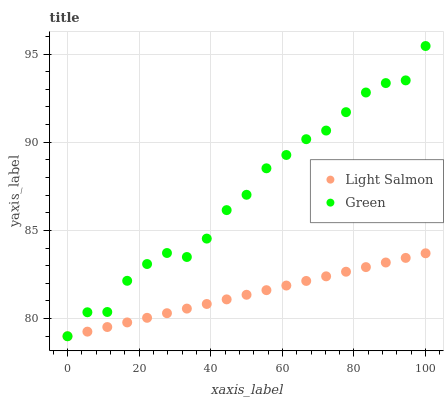Does Light Salmon have the minimum area under the curve?
Answer yes or no. Yes. Does Green have the maximum area under the curve?
Answer yes or no. Yes. Does Green have the minimum area under the curve?
Answer yes or no. No. Is Light Salmon the smoothest?
Answer yes or no. Yes. Is Green the roughest?
Answer yes or no. Yes. Is Green the smoothest?
Answer yes or no. No. Does Light Salmon have the lowest value?
Answer yes or no. Yes. Does Green have the highest value?
Answer yes or no. Yes. Does Light Salmon intersect Green?
Answer yes or no. Yes. Is Light Salmon less than Green?
Answer yes or no. No. Is Light Salmon greater than Green?
Answer yes or no. No. 